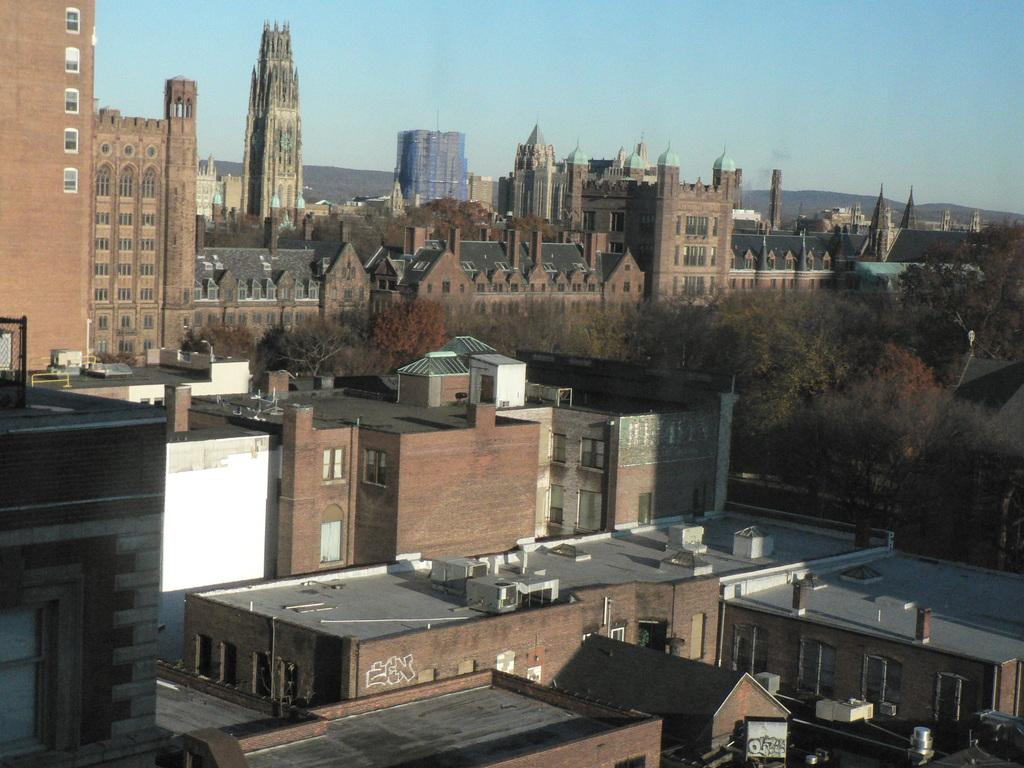What type of structures can be seen in the image? There are buildings, towers, and mountains in the image. What type of natural elements are present in the image? There are trees and mountains in the image. What is visible in the sky in the image? The sky is visible in the image. Can you determine the time of day the image was taken? The image was likely taken during the day, as there is no indication of darkness or artificial lighting. What type of pet can be seen playing with a bird in the image? There is no pet or bird present in the image; it features buildings, towers, trees, mountains, and the sky. 